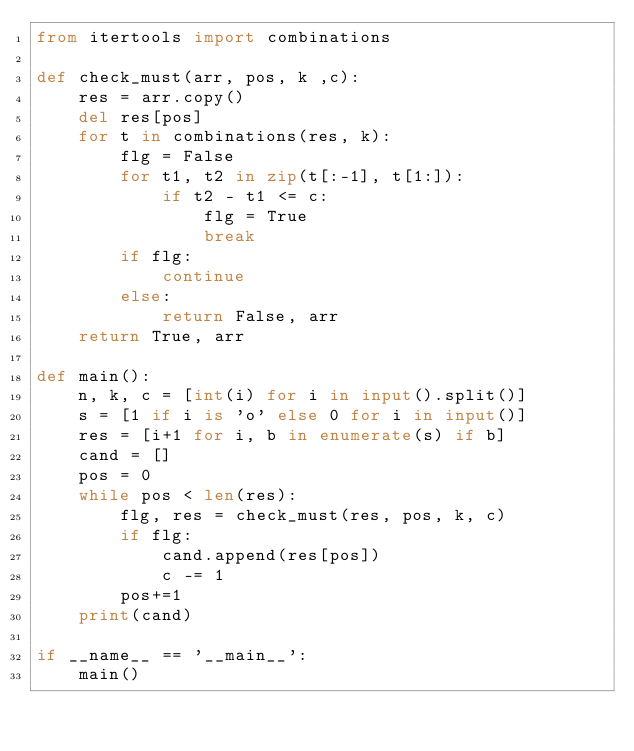<code> <loc_0><loc_0><loc_500><loc_500><_Python_>from itertools import combinations

def check_must(arr, pos, k ,c):
    res = arr.copy()
    del res[pos]
    for t in combinations(res, k):
        flg = False
        for t1, t2 in zip(t[:-1], t[1:]):
            if t2 - t1 <= c:
                flg = True
                break
        if flg:
            continue
        else:
            return False, arr
    return True, arr

def main():
    n, k, c = [int(i) for i in input().split()]
    s = [1 if i is 'o' else 0 for i in input()]
    res = [i+1 for i, b in enumerate(s) if b]
    cand = []
    pos = 0
    while pos < len(res):
        flg, res = check_must(res, pos, k, c)
        if flg:
            cand.append(res[pos])
            c -= 1
        pos+=1
    print(cand)
    
if __name__ == '__main__':
    main()

</code> 